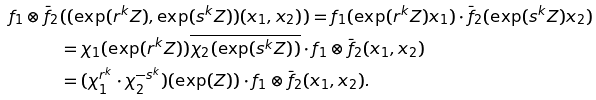Convert formula to latex. <formula><loc_0><loc_0><loc_500><loc_500>f _ { 1 } \otimes \bar { f } _ { 2 } & ( ( \exp ( r ^ { k } Z ) , \exp ( s ^ { k } Z ) ) ( x _ { 1 } , x _ { 2 } ) ) = f _ { 1 } ( \exp ( r ^ { k } Z ) x _ { 1 } ) \cdot \bar { f } _ { 2 } ( \exp ( s ^ { k } Z ) x _ { 2 } ) \\ & = \chi _ { 1 } ( \exp ( r ^ { k } Z ) ) \overline { \chi _ { 2 } ( \exp ( s ^ { k } Z ) ) } \cdot f _ { 1 } \otimes \bar { f } _ { 2 } ( x _ { 1 } , x _ { 2 } ) \\ & = ( \chi _ { 1 } ^ { r ^ { k } } \cdot \chi _ { 2 } ^ { - s ^ { k } } ) ( \exp ( Z ) ) \cdot f _ { 1 } \otimes \bar { f } _ { 2 } ( x _ { 1 } , x _ { 2 } ) .</formula> 